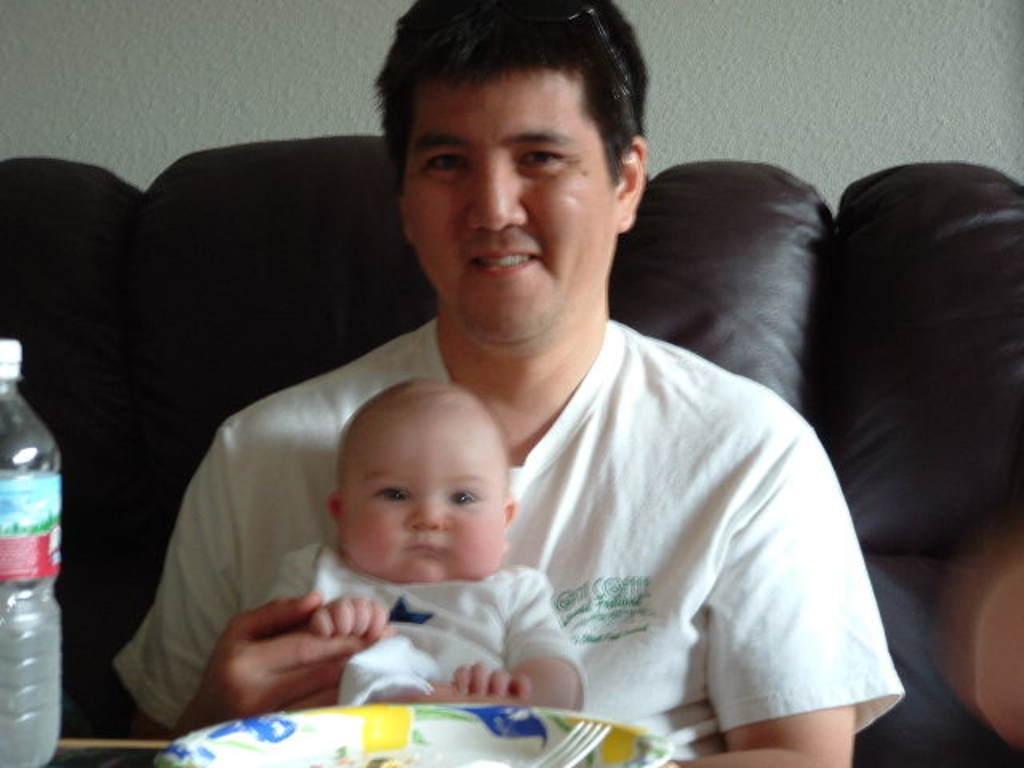Can you describe this image briefly? This picture is clicked inside the city. Here, we see a man in white T-shirt is carrying baby in his hands and he is smiling. In front of him, we see a table on which plate, fork and bottle water bottle are placed. He is sitting on sofa. Behind him, we see white wall. 